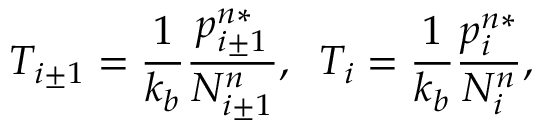Convert formula to latex. <formula><loc_0><loc_0><loc_500><loc_500>T _ { i \pm 1 } = \frac { 1 } { k _ { b } } \frac { p _ { i \pm 1 } ^ { n * } } { N _ { i \pm 1 } ^ { n } } , \, T _ { i } = \frac { 1 } { k _ { b } } \frac { p _ { i } ^ { n * } } { N _ { i } ^ { n } } ,</formula> 